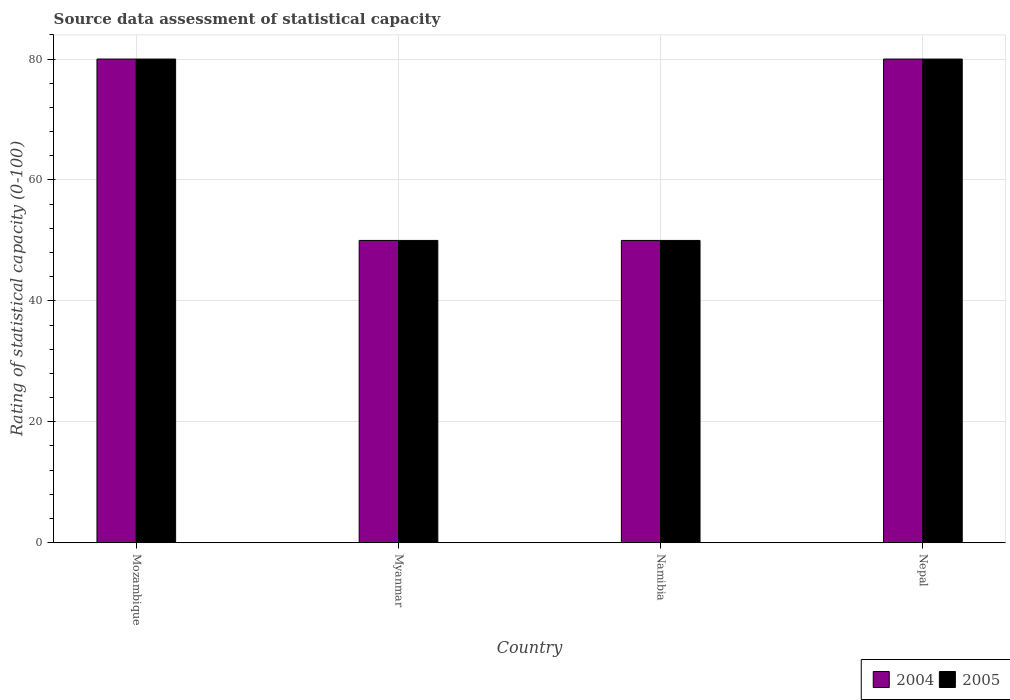How many different coloured bars are there?
Provide a short and direct response. 2. Are the number of bars per tick equal to the number of legend labels?
Ensure brevity in your answer.  Yes. How many bars are there on the 2nd tick from the left?
Make the answer very short. 2. What is the label of the 3rd group of bars from the left?
Offer a very short reply. Namibia. In how many cases, is the number of bars for a given country not equal to the number of legend labels?
Make the answer very short. 0. Across all countries, what is the maximum rating of statistical capacity in 2005?
Offer a terse response. 80. Across all countries, what is the minimum rating of statistical capacity in 2005?
Provide a succinct answer. 50. In which country was the rating of statistical capacity in 2005 maximum?
Your answer should be compact. Mozambique. In which country was the rating of statistical capacity in 2005 minimum?
Ensure brevity in your answer.  Myanmar. What is the total rating of statistical capacity in 2004 in the graph?
Your answer should be very brief. 260. What is the difference between the rating of statistical capacity in 2004 in Mozambique and that in Myanmar?
Keep it short and to the point. 30. What is the difference between the rating of statistical capacity in 2005 in Myanmar and the rating of statistical capacity in 2004 in Mozambique?
Offer a terse response. -30. What is the difference between the rating of statistical capacity of/in 2005 and rating of statistical capacity of/in 2004 in Myanmar?
Provide a succinct answer. 0. In how many countries, is the rating of statistical capacity in 2005 greater than the average rating of statistical capacity in 2005 taken over all countries?
Provide a short and direct response. 2. Is the sum of the rating of statistical capacity in 2005 in Namibia and Nepal greater than the maximum rating of statistical capacity in 2004 across all countries?
Your response must be concise. Yes. What does the 1st bar from the left in Namibia represents?
Provide a succinct answer. 2004. How many bars are there?
Make the answer very short. 8. How many countries are there in the graph?
Keep it short and to the point. 4. What is the difference between two consecutive major ticks on the Y-axis?
Keep it short and to the point. 20. Are the values on the major ticks of Y-axis written in scientific E-notation?
Make the answer very short. No. Does the graph contain any zero values?
Provide a succinct answer. No. Does the graph contain grids?
Keep it short and to the point. Yes. How many legend labels are there?
Offer a very short reply. 2. How are the legend labels stacked?
Keep it short and to the point. Horizontal. What is the title of the graph?
Give a very brief answer. Source data assessment of statistical capacity. What is the label or title of the X-axis?
Ensure brevity in your answer.  Country. What is the label or title of the Y-axis?
Make the answer very short. Rating of statistical capacity (0-100). What is the Rating of statistical capacity (0-100) in 2004 in Mozambique?
Make the answer very short. 80. What is the Rating of statistical capacity (0-100) of 2004 in Myanmar?
Provide a short and direct response. 50. What is the Rating of statistical capacity (0-100) of 2005 in Namibia?
Ensure brevity in your answer.  50. Across all countries, what is the minimum Rating of statistical capacity (0-100) in 2005?
Offer a very short reply. 50. What is the total Rating of statistical capacity (0-100) in 2004 in the graph?
Your answer should be compact. 260. What is the total Rating of statistical capacity (0-100) in 2005 in the graph?
Your response must be concise. 260. What is the difference between the Rating of statistical capacity (0-100) of 2004 in Mozambique and that in Myanmar?
Keep it short and to the point. 30. What is the difference between the Rating of statistical capacity (0-100) of 2005 in Mozambique and that in Myanmar?
Offer a terse response. 30. What is the difference between the Rating of statistical capacity (0-100) in 2004 in Myanmar and that in Nepal?
Your response must be concise. -30. What is the difference between the Rating of statistical capacity (0-100) in 2005 in Myanmar and that in Nepal?
Keep it short and to the point. -30. What is the difference between the Rating of statistical capacity (0-100) of 2005 in Namibia and that in Nepal?
Your response must be concise. -30. What is the difference between the Rating of statistical capacity (0-100) of 2004 in Namibia and the Rating of statistical capacity (0-100) of 2005 in Nepal?
Offer a terse response. -30. What is the average Rating of statistical capacity (0-100) of 2005 per country?
Your answer should be compact. 65. What is the difference between the Rating of statistical capacity (0-100) in 2004 and Rating of statistical capacity (0-100) in 2005 in Mozambique?
Offer a very short reply. 0. What is the difference between the Rating of statistical capacity (0-100) of 2004 and Rating of statistical capacity (0-100) of 2005 in Myanmar?
Provide a short and direct response. 0. What is the difference between the Rating of statistical capacity (0-100) in 2004 and Rating of statistical capacity (0-100) in 2005 in Nepal?
Keep it short and to the point. 0. What is the ratio of the Rating of statistical capacity (0-100) of 2005 in Mozambique to that in Myanmar?
Keep it short and to the point. 1.6. What is the ratio of the Rating of statistical capacity (0-100) of 2004 in Mozambique to that in Namibia?
Give a very brief answer. 1.6. What is the ratio of the Rating of statistical capacity (0-100) in 2005 in Mozambique to that in Namibia?
Offer a very short reply. 1.6. What is the ratio of the Rating of statistical capacity (0-100) in 2004 in Myanmar to that in Nepal?
Make the answer very short. 0.62. What is the ratio of the Rating of statistical capacity (0-100) in 2005 in Myanmar to that in Nepal?
Your answer should be very brief. 0.62. What is the difference between the highest and the second highest Rating of statistical capacity (0-100) of 2004?
Your answer should be very brief. 0. What is the difference between the highest and the lowest Rating of statistical capacity (0-100) of 2004?
Your response must be concise. 30. What is the difference between the highest and the lowest Rating of statistical capacity (0-100) of 2005?
Keep it short and to the point. 30. 